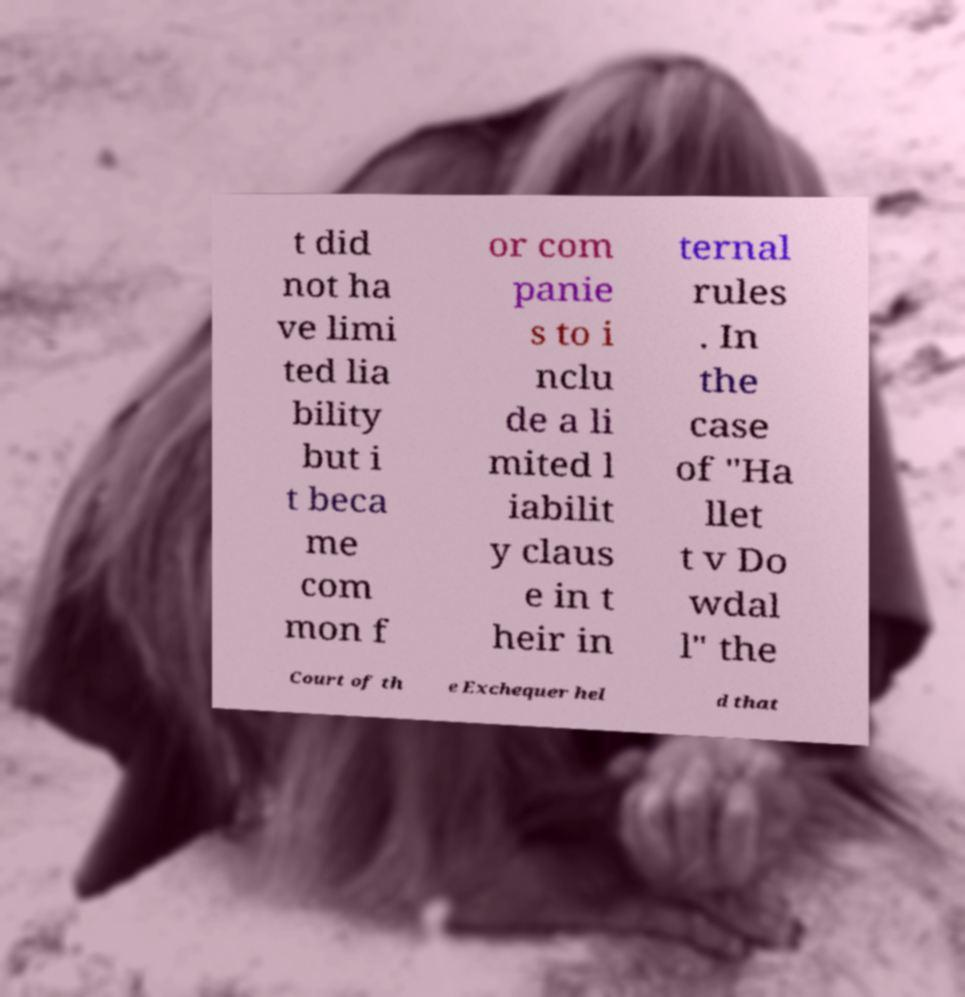For documentation purposes, I need the text within this image transcribed. Could you provide that? t did not ha ve limi ted lia bility but i t beca me com mon f or com panie s to i nclu de a li mited l iabilit y claus e in t heir in ternal rules . In the case of "Ha llet t v Do wdal l" the Court of th e Exchequer hel d that 